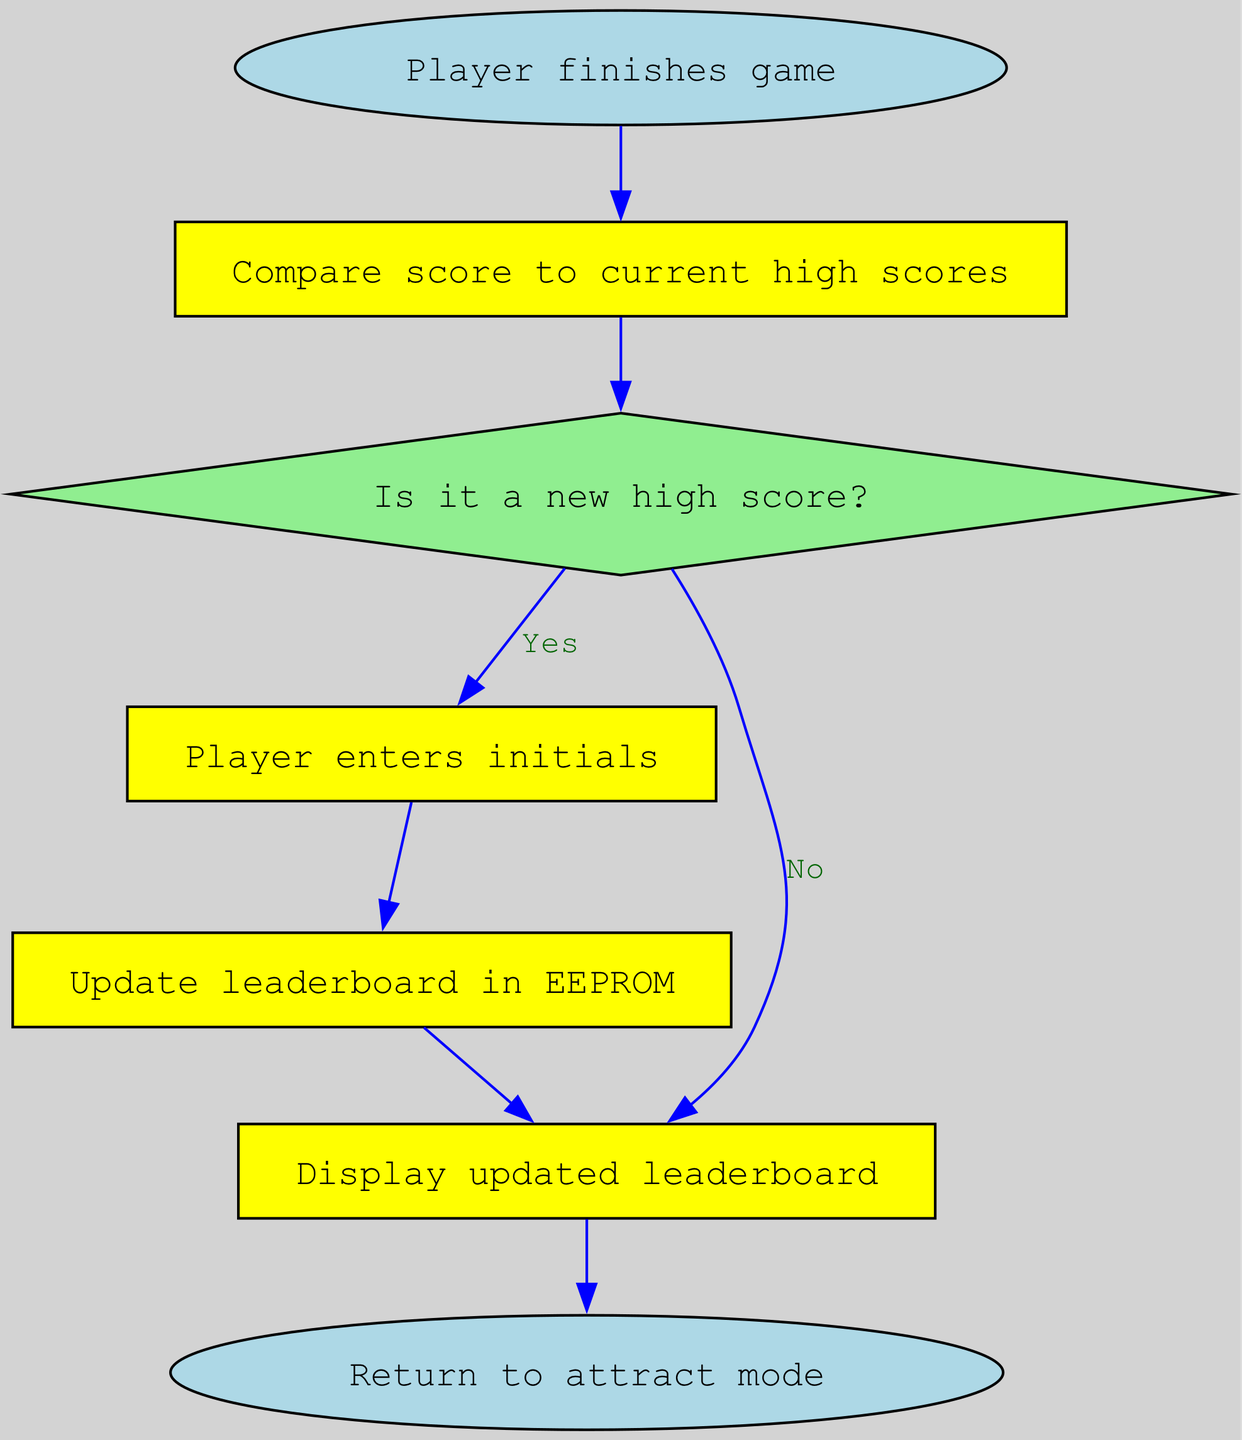What is the first action after a player finishes the game? The process begins with the "Player finishes game" node, which is the starting point of the flowchart. This node directly connects to the next node, which is "Compare score to current high scores."
Answer: Compare score to current high scores How many nodes are present in the flowchart? The diagram consists of six nodes, which are "Player finishes game," "Compare score to current high scores," "Is it a new high score?," "Player enters initials," "Update leaderboard in EEPROM," and "Display updated leaderboard."
Answer: Six What shape is used for the 'Is it a new high score?' decision? The 'Is it a new high score?' node is shaped like a diamond, which is a standard representation for decision-making points in flowcharts.
Answer: Diamond What happens if the score is not a new high score? If the score is not a new high score, the flowchart indicates that the next action is to "Display updated leaderboard," bypassing the node where initials are entered.
Answer: Display updated leaderboard How does the flowchart conclude after displaying the leaderboard? After displaying the updated leaderboard, the process concludes with the "Return to attract mode" node, which indicates the end of the scoring process.
Answer: Return to attract mode What action follows after the player enters their initials? Following the player entering their initials, the next step is to "Update leaderboard in EEPROM," which is a critical action for saving the new high score.
Answer: Update leaderboard in EEPROM What is the relationship between 'Compare score to current high scores' and 'Is it a new high score?' The 'Compare score to current high scores' node directly leads to the 'Is it a new high score?' node, indicating that after the score comparison, a decision about the high score status is made.
Answer: Directly leads to What node type represents the end of the process in this flowchart? The end of the process is represented by an oval-shaped node labeled "Return to attract mode," which signifies that the flowchart completes at this point.
Answer: Oval 